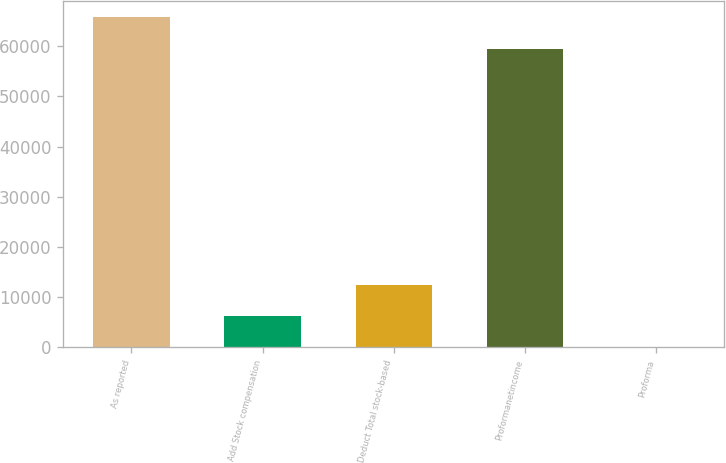Convert chart to OTSL. <chart><loc_0><loc_0><loc_500><loc_500><bar_chart><fcel>As reported<fcel>Add Stock compensation<fcel>Deduct Total stock-based<fcel>Proformanetincome<fcel>Proforma<nl><fcel>65742.1<fcel>6245.73<fcel>12489.9<fcel>59498<fcel>1.59<nl></chart> 